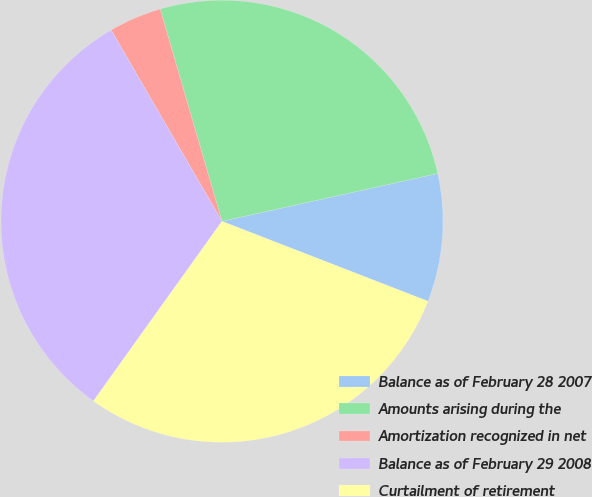Convert chart to OTSL. <chart><loc_0><loc_0><loc_500><loc_500><pie_chart><fcel>Balance as of February 28 2007<fcel>Amounts arising during the<fcel>Amortization recognized in net<fcel>Balance as of February 29 2008<fcel>Curtailment of retirement<nl><fcel>9.36%<fcel>26.04%<fcel>3.85%<fcel>31.76%<fcel>28.99%<nl></chart> 